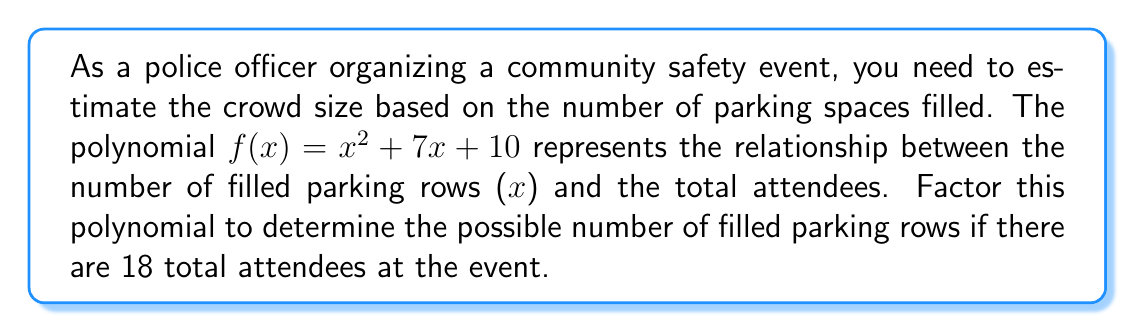Can you solve this math problem? To solve this problem, we need to follow these steps:

1) First, we need to factor the given polynomial $f(x) = x^2 + 7x + 10$

2) To factor this quadratic equation, we look for two numbers that multiply to give the constant term (10) and add up to give the coefficient of x (7).

3) The factors of 10 are: 1 and 10, 2 and 5. We see that 2 + 5 = 7, so these are the numbers we need.

4) We can rewrite the middle term as: $x^2 + 2x + 5x + 10$

5) Now we can factor by grouping:
   $x^2 + 2x + 5x + 10 = x(x + 2) + 5(x + 2) = (x + 5)(x + 2)$

6) So, the factored form of the polynomial is: $f(x) = (x + 5)(x + 2)$

7) Now, to find the number of filled parking rows when there are 18 attendees, we set $f(x) = 18$:

   $(x + 5)(x + 2) = 18$

8) To solve this, we can use the zero product property. If $(x + 5)(x + 2) = 18$, then either $(x + 5) = 18$ and $(x + 2) = 1$, or $(x + 5) = 9$ and $(x + 2) = 2$, or $(x + 5) = 6$ and $(x + 2) = 3$, and so on.

9) Solving these equations:
   If $x + 5 = 9$, then $x = 4$
   If $x + 2 = 2$, then $x = 0$

10) Since x represents the number of filled parking rows, it can't be negative or zero. Therefore, the only valid solution is x = 4.
Answer: There will be 4 filled parking rows when there are 18 attendees at the community safety event. 